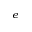Convert formula to latex. <formula><loc_0><loc_0><loc_500><loc_500>^ { e }</formula> 